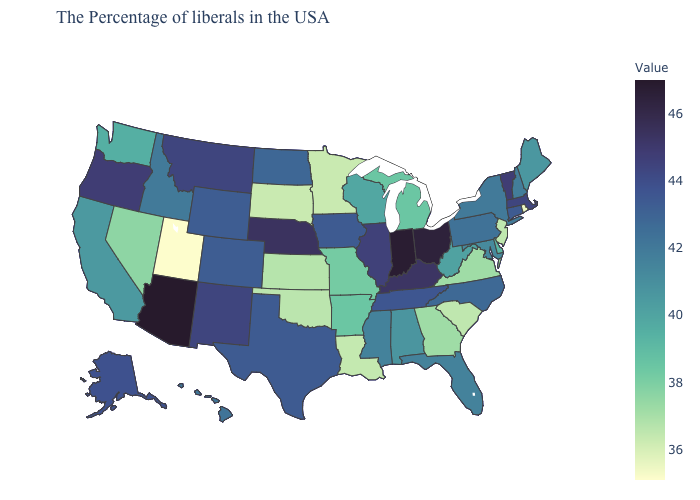Does North Dakota have the lowest value in the MidWest?
Keep it brief. No. Among the states that border Delaware , which have the highest value?
Give a very brief answer. Pennsylvania. Which states have the lowest value in the Northeast?
Concise answer only. Rhode Island. Does Arizona have the highest value in the USA?
Keep it brief. Yes. 